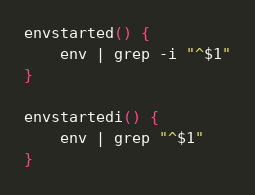Convert code to text. <code><loc_0><loc_0><loc_500><loc_500><_Bash_>envstarted() {
    env | grep -i "^$1"
}

envstartedi() {
    env | grep "^$1"
}
</code> 